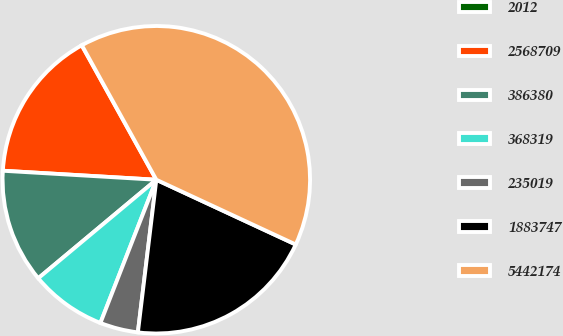Convert chart to OTSL. <chart><loc_0><loc_0><loc_500><loc_500><pie_chart><fcel>2012<fcel>2568709<fcel>386380<fcel>368319<fcel>235019<fcel>1883747<fcel>5442174<nl><fcel>0.02%<fcel>16.0%<fcel>12.0%<fcel>8.01%<fcel>4.01%<fcel>19.99%<fcel>39.97%<nl></chart> 